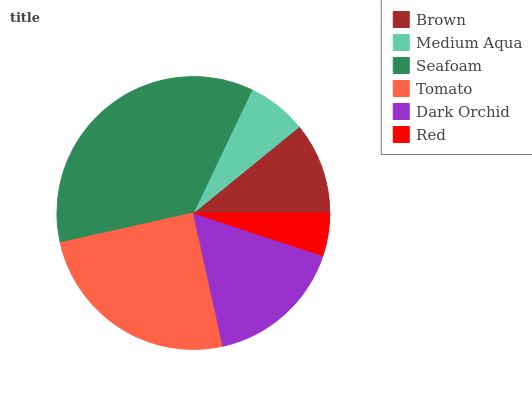Is Red the minimum?
Answer yes or no. Yes. Is Seafoam the maximum?
Answer yes or no. Yes. Is Medium Aqua the minimum?
Answer yes or no. No. Is Medium Aqua the maximum?
Answer yes or no. No. Is Brown greater than Medium Aqua?
Answer yes or no. Yes. Is Medium Aqua less than Brown?
Answer yes or no. Yes. Is Medium Aqua greater than Brown?
Answer yes or no. No. Is Brown less than Medium Aqua?
Answer yes or no. No. Is Dark Orchid the high median?
Answer yes or no. Yes. Is Brown the low median?
Answer yes or no. Yes. Is Tomato the high median?
Answer yes or no. No. Is Medium Aqua the low median?
Answer yes or no. No. 